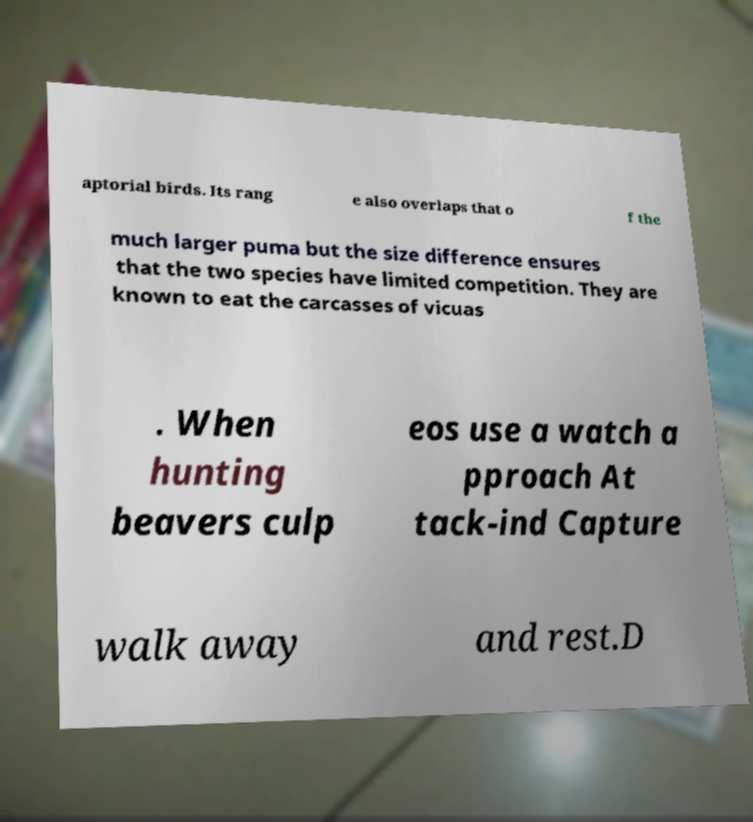For documentation purposes, I need the text within this image transcribed. Could you provide that? aptorial birds. Its rang e also overlaps that o f the much larger puma but the size difference ensures that the two species have limited competition. They are known to eat the carcasses of vicuas . When hunting beavers culp eos use a watch a pproach At tack-ind Capture walk away and rest.D 